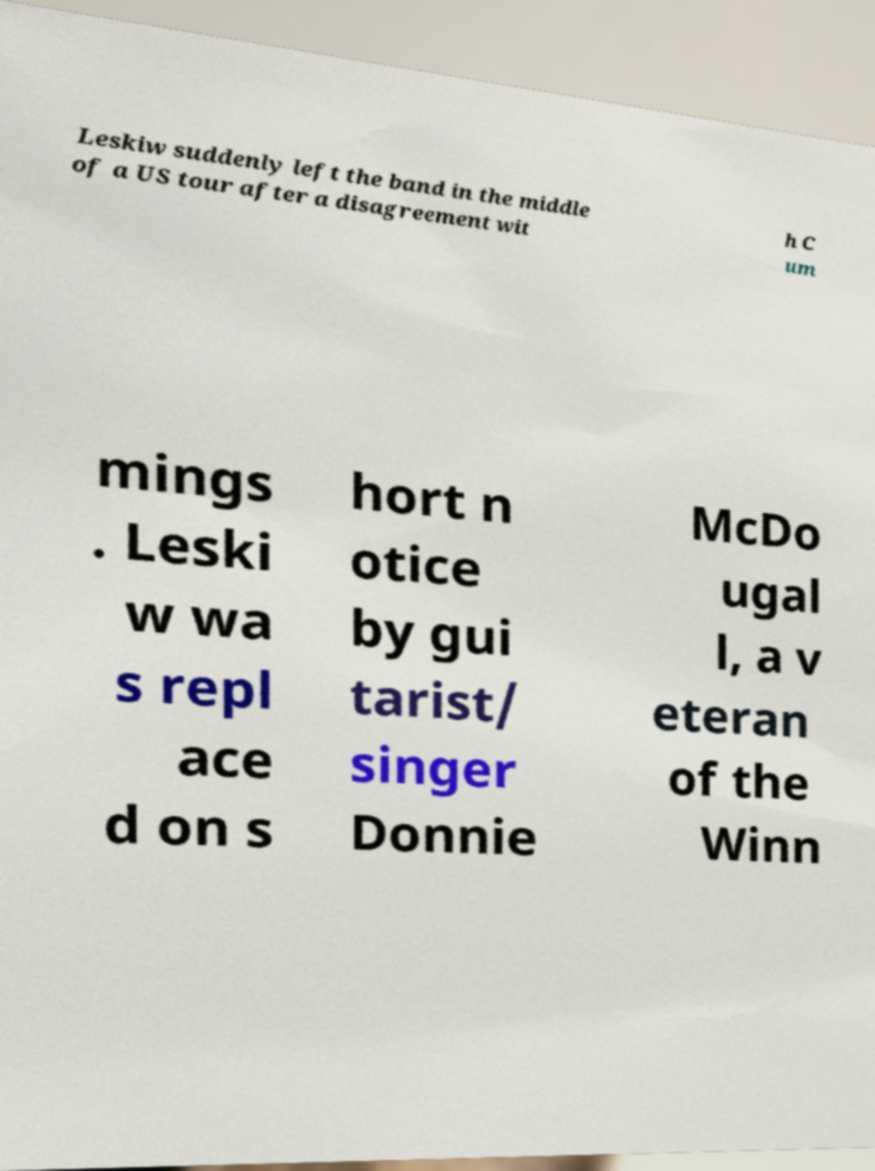There's text embedded in this image that I need extracted. Can you transcribe it verbatim? Leskiw suddenly left the band in the middle of a US tour after a disagreement wit h C um mings . Leski w wa s repl ace d on s hort n otice by gui tarist/ singer Donnie McDo ugal l, a v eteran of the Winn 